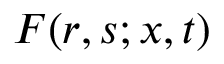Convert formula to latex. <formula><loc_0><loc_0><loc_500><loc_500>F ( r , s ; x , t )</formula> 